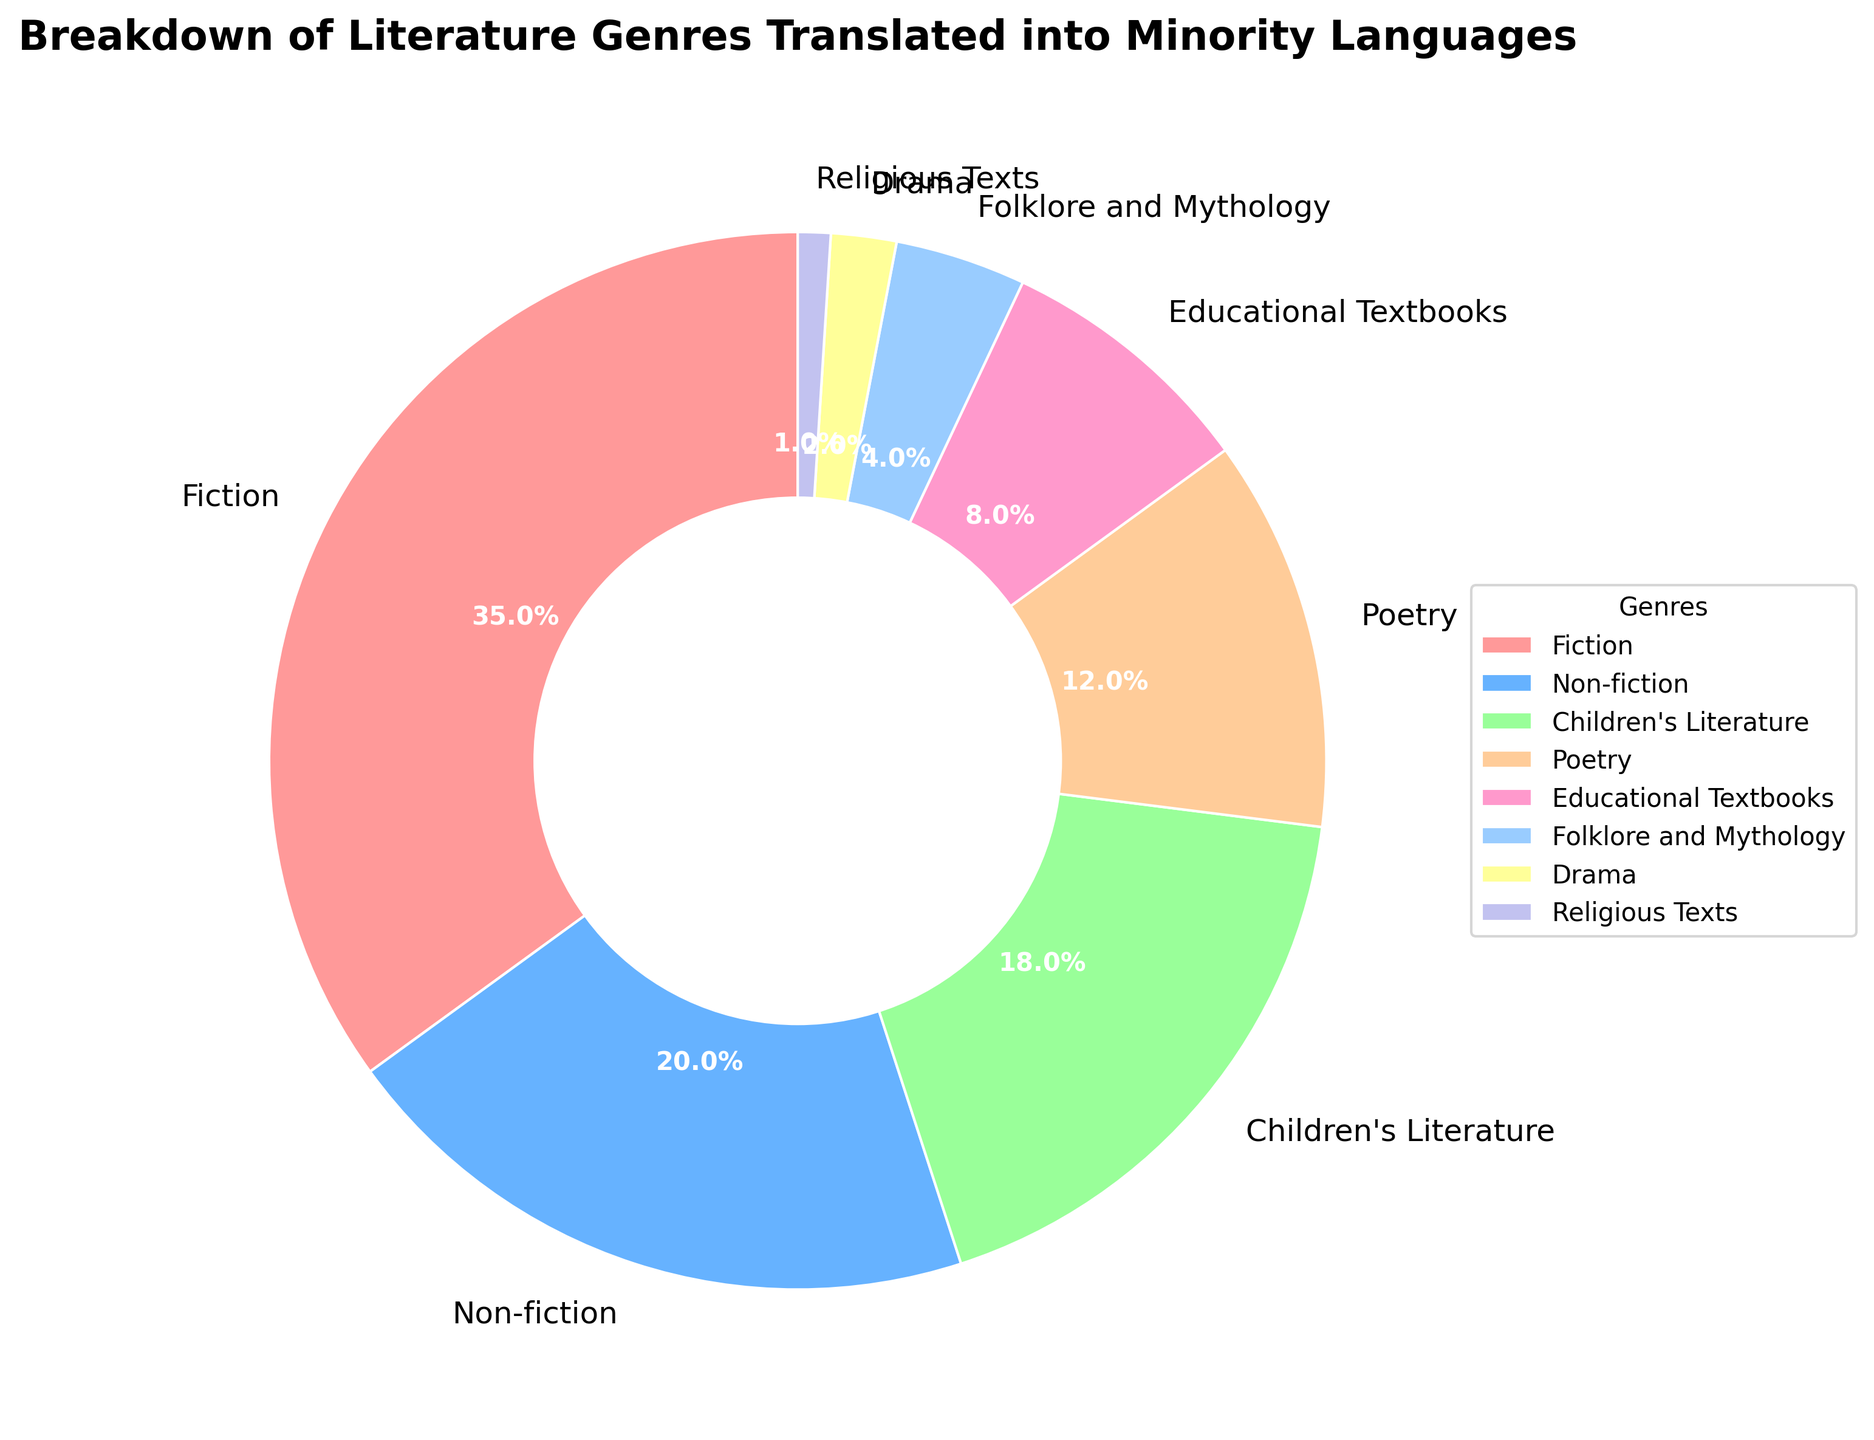Which genre has the highest percentage of literature translated into minority languages? By looking at the pie chart, it is clear that the largest wedge represents Fiction.
Answer: Fiction What is the combined percentage of Children's Literature and Poetry translated into minority languages? Children's Literature accounts for 18%, and Poetry accounts for 12%. The combined percentage is 18% + 12% = 30%.
Answer: 30% How much more literature is translated into minority languages in the Fiction genre than in the Non-fiction genre? Fiction accounts for 35%, and Non-fiction accounts for 20%. The difference is 35% - 20% = 15%.
Answer: 15% Which genre has the smallest percentage of literature translated into minority languages? By examining the pie chart, it is observed that Religious Texts have the smallest wedge, representing 1%.
Answer: Religious Texts Are there more literature genres with less than 10% translation or more than 10% translation into minority languages? The genres with less than 10% translation: Educational Textbooks (8%), Folklore and Mythology (4%), Drama (2%), Religious Texts (1%)—a total of 4 genres. The genres with more than 10% translation: Fiction (35%), Non-fiction (20%), Children's Literature (18%), Poetry (12%)—a total of 4 genres. Since both groups have the same number (4), the answer is neither.
Answer: Neither Which genre translated into minority languages appears in green on the pie chart? Based on the custom color palette provided, Fiction is represented in red, Non-fiction in blue, and Children's Literature in green in the pie chart.
Answer: Children's Literature Sum the percentages of the two genres with the smallest translation into minority languages. The two genres with the smallest percentages are Religious Texts (1%) and Drama (2%). The sum is 1% + 2% = 3%.
Answer: 3% Which genres account for more than one-third of the total literature translations into minority languages? One-third of the total is approximately 33.3%. By observing the pie chart, Fiction is the only genre with 35%, which is more than 33.3%.
Answer: Fiction How does the percentage of Fiction compare to the combined percentage of Drama and Folklore and Mythology? Fiction accounts for 35%, while Drama has 2% and Folklore and Mythology has 4%. Their combined percentage is 2% + 4% = 6%. Therefore, Fiction's 35% is greater than the combined 6%.
Answer: Fiction is greater 